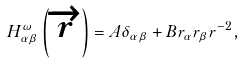<formula> <loc_0><loc_0><loc_500><loc_500>H _ { \alpha \beta } ^ { \omega } \left ( \overrightarrow { r } \right ) = A \delta _ { \alpha \beta } + B r _ { \alpha } r _ { \beta } r ^ { - 2 } ,</formula> 